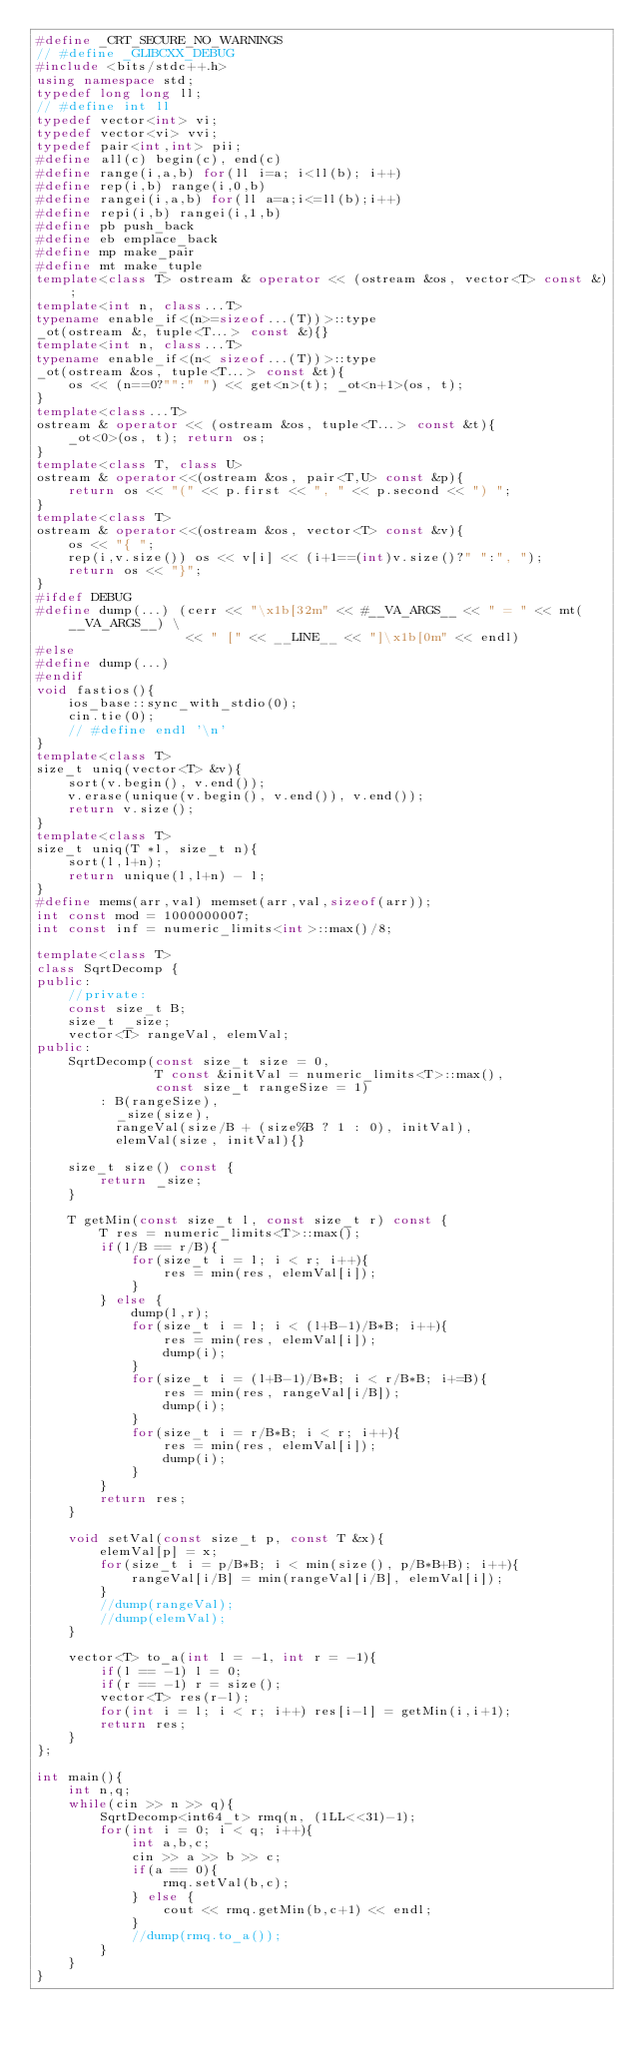Convert code to text. <code><loc_0><loc_0><loc_500><loc_500><_C++_>#define _CRT_SECURE_NO_WARNINGS
// #define _GLIBCXX_DEBUG
#include <bits/stdc++.h>
using namespace std;
typedef long long ll;
// #define int ll
typedef vector<int> vi;
typedef vector<vi> vvi;
typedef pair<int,int> pii;
#define all(c) begin(c), end(c)
#define range(i,a,b) for(ll i=a; i<ll(b); i++)
#define rep(i,b) range(i,0,b)
#define rangei(i,a,b) for(ll a=a;i<=ll(b);i++)
#define repi(i,b) rangei(i,1,b)
#define pb push_back
#define eb emplace_back
#define mp make_pair
#define mt make_tuple
template<class T> ostream & operator << (ostream &os, vector<T> const &);
template<int n, class...T>
typename enable_if<(n>=sizeof...(T))>::type
_ot(ostream &, tuple<T...> const &){}
template<int n, class...T>
typename enable_if<(n< sizeof...(T))>::type
_ot(ostream &os, tuple<T...> const &t){
    os << (n==0?"":" ") << get<n>(t); _ot<n+1>(os, t);
}
template<class...T>
ostream & operator << (ostream &os, tuple<T...> const &t){
    _ot<0>(os, t); return os;
}
template<class T, class U>
ostream & operator<<(ostream &os, pair<T,U> const &p){
    return os << "(" << p.first << ", " << p.second << ") ";
}
template<class T>
ostream & operator<<(ostream &os, vector<T> const &v){
    os << "{ ";
    rep(i,v.size()) os << v[i] << (i+1==(int)v.size()?" ":", ");
    return os << "}";
}
#ifdef DEBUG
#define dump(...) (cerr << "\x1b[32m" << #__VA_ARGS__ << " = " << mt(__VA_ARGS__) \
                   << " [" << __LINE__ << "]\x1b[0m" << endl)
#else
#define dump(...)
#endif
void fastios(){
    ios_base::sync_with_stdio(0);
    cin.tie(0);
    // #define endl '\n'
}
template<class T>
size_t uniq(vector<T> &v){
    sort(v.begin(), v.end());
    v.erase(unique(v.begin(), v.end()), v.end());
    return v.size();
}
template<class T>
size_t uniq(T *l, size_t n){
    sort(l,l+n);
    return unique(l,l+n) - l;
}
#define mems(arr,val) memset(arr,val,sizeof(arr));
int const mod = 1000000007;
int const inf = numeric_limits<int>::max()/8;

template<class T>
class SqrtDecomp {
public:
    //private:
    const size_t B;
    size_t _size;
    vector<T> rangeVal, elemVal;
public:
    SqrtDecomp(const size_t size = 0,
               T const &initVal = numeric_limits<T>::max(),
               const size_t rangeSize = 1)
        : B(rangeSize),
          _size(size),
          rangeVal(size/B + (size%B ? 1 : 0), initVal),
          elemVal(size, initVal){}

    size_t size() const {
        return _size;
    }

    T getMin(const size_t l, const size_t r) const {
        T res = numeric_limits<T>::max();
        if(l/B == r/B){
            for(size_t i = l; i < r; i++){
                res = min(res, elemVal[i]);
            }
        } else {
            dump(l,r);
            for(size_t i = l; i < (l+B-1)/B*B; i++){
                res = min(res, elemVal[i]);
                dump(i);
            }
            for(size_t i = (l+B-1)/B*B; i < r/B*B; i+=B){
                res = min(res, rangeVal[i/B]);
                dump(i);
            }
            for(size_t i = r/B*B; i < r; i++){
                res = min(res, elemVal[i]);
                dump(i);
            }
        }
        return res;
    }

    void setVal(const size_t p, const T &x){
        elemVal[p] = x;
        for(size_t i = p/B*B; i < min(size(), p/B*B+B); i++){
            rangeVal[i/B] = min(rangeVal[i/B], elemVal[i]);
        }
        //dump(rangeVal);
        //dump(elemVal);
    }

    vector<T> to_a(int l = -1, int r = -1){
        if(l == -1) l = 0;
        if(r == -1) r = size();
        vector<T> res(r-l);
        for(int i = l; i < r; i++) res[i-l] = getMin(i,i+1);
        return res;
    }
};

int main(){
    int n,q;
    while(cin >> n >> q){
        SqrtDecomp<int64_t> rmq(n, (1LL<<31)-1);
        for(int i = 0; i < q; i++){
            int a,b,c;
            cin >> a >> b >> c;
            if(a == 0){
                rmq.setVal(b,c);
            } else {
                cout << rmq.getMin(b,c+1) << endl;
            }
            //dump(rmq.to_a());
        }
    }
}</code> 